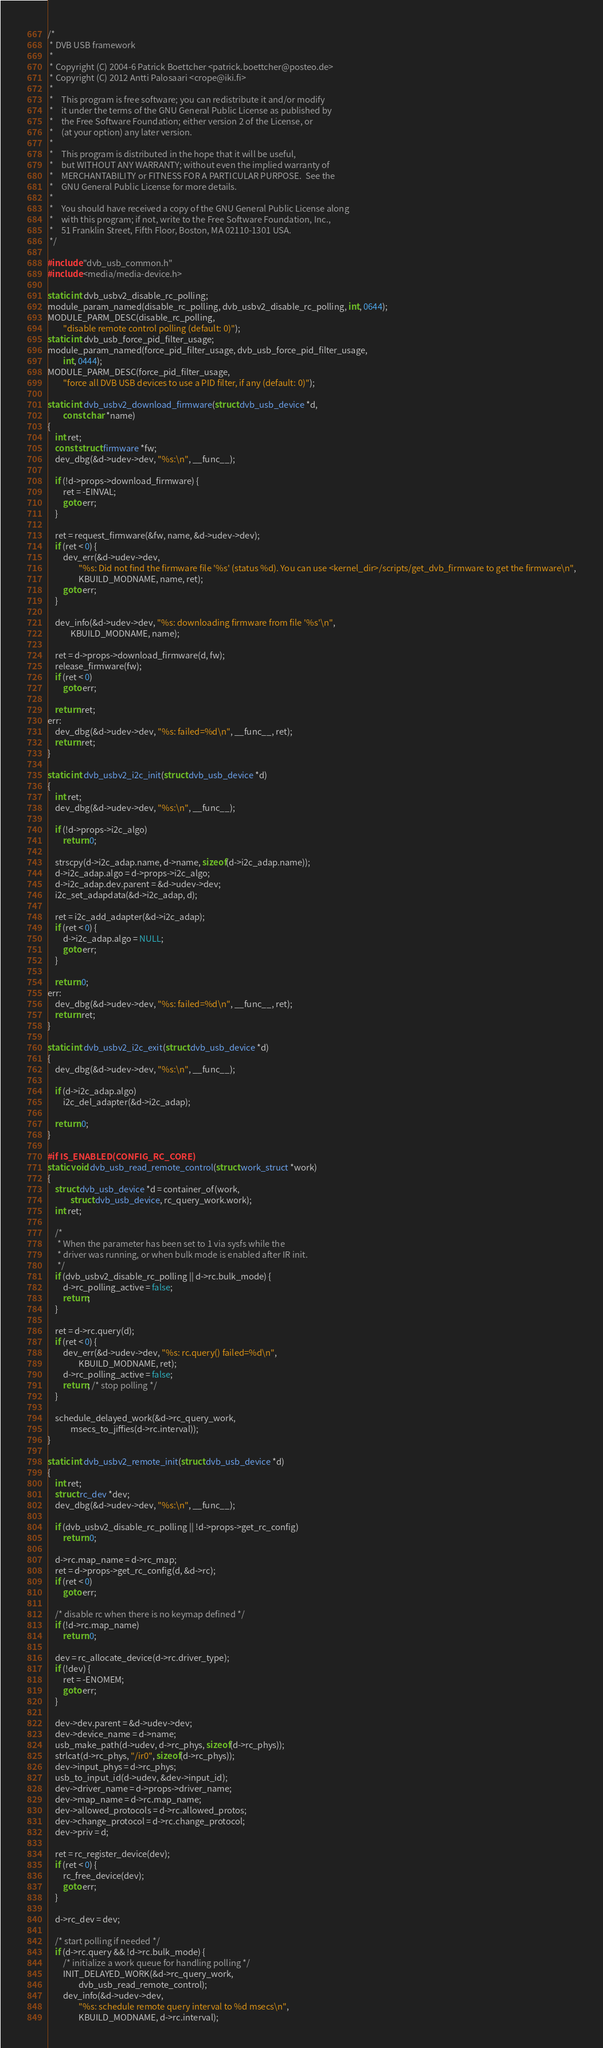<code> <loc_0><loc_0><loc_500><loc_500><_C_>/*
 * DVB USB framework
 *
 * Copyright (C) 2004-6 Patrick Boettcher <patrick.boettcher@posteo.de>
 * Copyright (C) 2012 Antti Palosaari <crope@iki.fi>
 *
 *    This program is free software; you can redistribute it and/or modify
 *    it under the terms of the GNU General Public License as published by
 *    the Free Software Foundation; either version 2 of the License, or
 *    (at your option) any later version.
 *
 *    This program is distributed in the hope that it will be useful,
 *    but WITHOUT ANY WARRANTY; without even the implied warranty of
 *    MERCHANTABILITY or FITNESS FOR A PARTICULAR PURPOSE.  See the
 *    GNU General Public License for more details.
 *
 *    You should have received a copy of the GNU General Public License along
 *    with this program; if not, write to the Free Software Foundation, Inc.,
 *    51 Franklin Street, Fifth Floor, Boston, MA 02110-1301 USA.
 */

#include "dvb_usb_common.h"
#include <media/media-device.h>

static int dvb_usbv2_disable_rc_polling;
module_param_named(disable_rc_polling, dvb_usbv2_disable_rc_polling, int, 0644);
MODULE_PARM_DESC(disable_rc_polling,
		"disable remote control polling (default: 0)");
static int dvb_usb_force_pid_filter_usage;
module_param_named(force_pid_filter_usage, dvb_usb_force_pid_filter_usage,
		int, 0444);
MODULE_PARM_DESC(force_pid_filter_usage,
		"force all DVB USB devices to use a PID filter, if any (default: 0)");

static int dvb_usbv2_download_firmware(struct dvb_usb_device *d,
		const char *name)
{
	int ret;
	const struct firmware *fw;
	dev_dbg(&d->udev->dev, "%s:\n", __func__);

	if (!d->props->download_firmware) {
		ret = -EINVAL;
		goto err;
	}

	ret = request_firmware(&fw, name, &d->udev->dev);
	if (ret < 0) {
		dev_err(&d->udev->dev,
				"%s: Did not find the firmware file '%s' (status %d). You can use <kernel_dir>/scripts/get_dvb_firmware to get the firmware\n",
				KBUILD_MODNAME, name, ret);
		goto err;
	}

	dev_info(&d->udev->dev, "%s: downloading firmware from file '%s'\n",
			KBUILD_MODNAME, name);

	ret = d->props->download_firmware(d, fw);
	release_firmware(fw);
	if (ret < 0)
		goto err;

	return ret;
err:
	dev_dbg(&d->udev->dev, "%s: failed=%d\n", __func__, ret);
	return ret;
}

static int dvb_usbv2_i2c_init(struct dvb_usb_device *d)
{
	int ret;
	dev_dbg(&d->udev->dev, "%s:\n", __func__);

	if (!d->props->i2c_algo)
		return 0;

	strscpy(d->i2c_adap.name, d->name, sizeof(d->i2c_adap.name));
	d->i2c_adap.algo = d->props->i2c_algo;
	d->i2c_adap.dev.parent = &d->udev->dev;
	i2c_set_adapdata(&d->i2c_adap, d);

	ret = i2c_add_adapter(&d->i2c_adap);
	if (ret < 0) {
		d->i2c_adap.algo = NULL;
		goto err;
	}

	return 0;
err:
	dev_dbg(&d->udev->dev, "%s: failed=%d\n", __func__, ret);
	return ret;
}

static int dvb_usbv2_i2c_exit(struct dvb_usb_device *d)
{
	dev_dbg(&d->udev->dev, "%s:\n", __func__);

	if (d->i2c_adap.algo)
		i2c_del_adapter(&d->i2c_adap);

	return 0;
}

#if IS_ENABLED(CONFIG_RC_CORE)
static void dvb_usb_read_remote_control(struct work_struct *work)
{
	struct dvb_usb_device *d = container_of(work,
			struct dvb_usb_device, rc_query_work.work);
	int ret;

	/*
	 * When the parameter has been set to 1 via sysfs while the
	 * driver was running, or when bulk mode is enabled after IR init.
	 */
	if (dvb_usbv2_disable_rc_polling || d->rc.bulk_mode) {
		d->rc_polling_active = false;
		return;
	}

	ret = d->rc.query(d);
	if (ret < 0) {
		dev_err(&d->udev->dev, "%s: rc.query() failed=%d\n",
				KBUILD_MODNAME, ret);
		d->rc_polling_active = false;
		return; /* stop polling */
	}

	schedule_delayed_work(&d->rc_query_work,
			msecs_to_jiffies(d->rc.interval));
}

static int dvb_usbv2_remote_init(struct dvb_usb_device *d)
{
	int ret;
	struct rc_dev *dev;
	dev_dbg(&d->udev->dev, "%s:\n", __func__);

	if (dvb_usbv2_disable_rc_polling || !d->props->get_rc_config)
		return 0;

	d->rc.map_name = d->rc_map;
	ret = d->props->get_rc_config(d, &d->rc);
	if (ret < 0)
		goto err;

	/* disable rc when there is no keymap defined */
	if (!d->rc.map_name)
		return 0;

	dev = rc_allocate_device(d->rc.driver_type);
	if (!dev) {
		ret = -ENOMEM;
		goto err;
	}

	dev->dev.parent = &d->udev->dev;
	dev->device_name = d->name;
	usb_make_path(d->udev, d->rc_phys, sizeof(d->rc_phys));
	strlcat(d->rc_phys, "/ir0", sizeof(d->rc_phys));
	dev->input_phys = d->rc_phys;
	usb_to_input_id(d->udev, &dev->input_id);
	dev->driver_name = d->props->driver_name;
	dev->map_name = d->rc.map_name;
	dev->allowed_protocols = d->rc.allowed_protos;
	dev->change_protocol = d->rc.change_protocol;
	dev->priv = d;

	ret = rc_register_device(dev);
	if (ret < 0) {
		rc_free_device(dev);
		goto err;
	}

	d->rc_dev = dev;

	/* start polling if needed */
	if (d->rc.query && !d->rc.bulk_mode) {
		/* initialize a work queue for handling polling */
		INIT_DELAYED_WORK(&d->rc_query_work,
				dvb_usb_read_remote_control);
		dev_info(&d->udev->dev,
				"%s: schedule remote query interval to %d msecs\n",
				KBUILD_MODNAME, d->rc.interval);</code> 